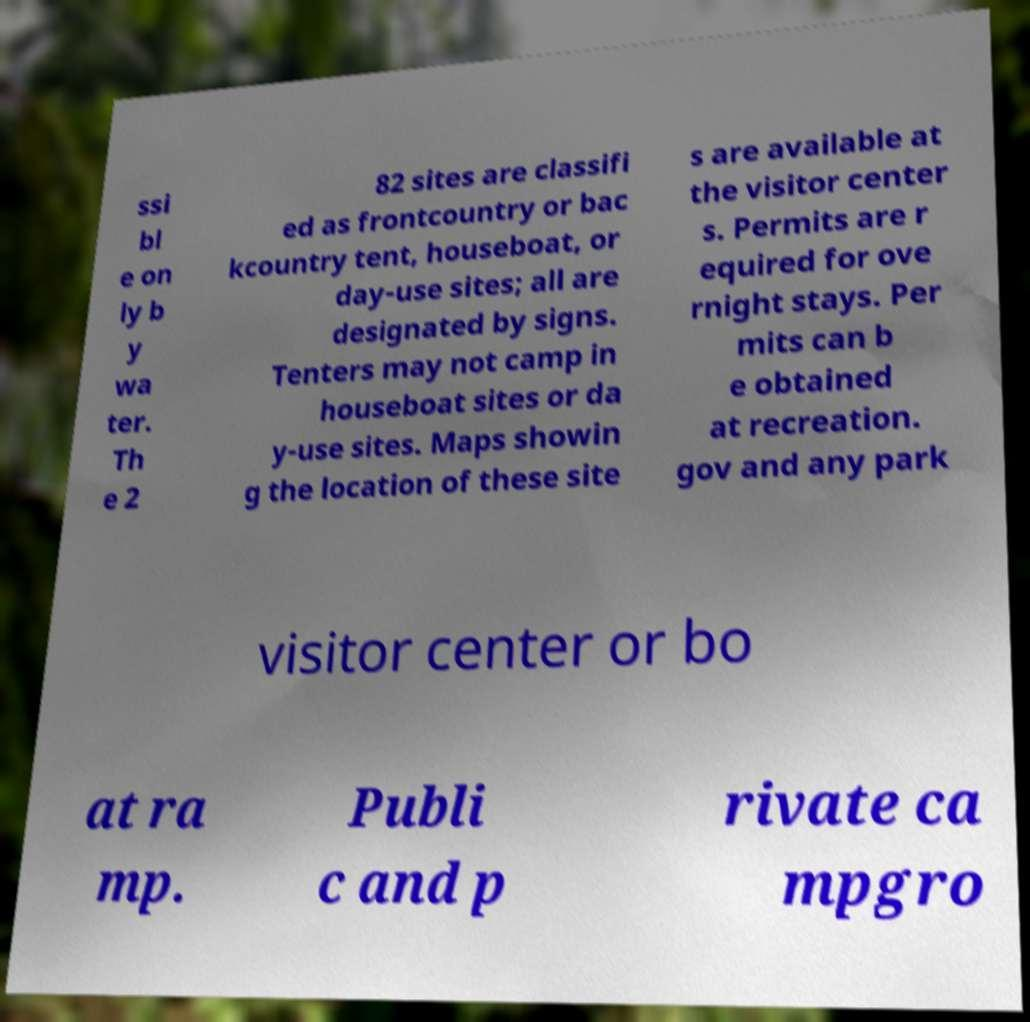Please read and relay the text visible in this image. What does it say? ssi bl e on ly b y wa ter. Th e 2 82 sites are classifi ed as frontcountry or bac kcountry tent, houseboat, or day-use sites; all are designated by signs. Tenters may not camp in houseboat sites or da y-use sites. Maps showin g the location of these site s are available at the visitor center s. Permits are r equired for ove rnight stays. Per mits can b e obtained at recreation. gov and any park visitor center or bo at ra mp. Publi c and p rivate ca mpgro 